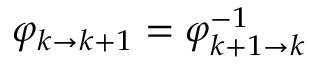Convert formula to latex. <formula><loc_0><loc_0><loc_500><loc_500>\varphi _ { k \to k + 1 } = \varphi _ { k + 1 \to k } ^ { - 1 }</formula> 